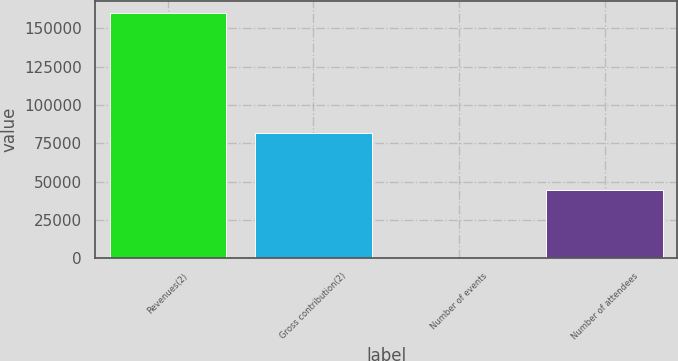Convert chart. <chart><loc_0><loc_0><loc_500><loc_500><bar_chart><fcel>Revenues(2)<fcel>Gross contribution(2)<fcel>Number of events<fcel>Number of attendees<nl><fcel>160065<fcel>81908<fcel>62<fcel>44216<nl></chart> 